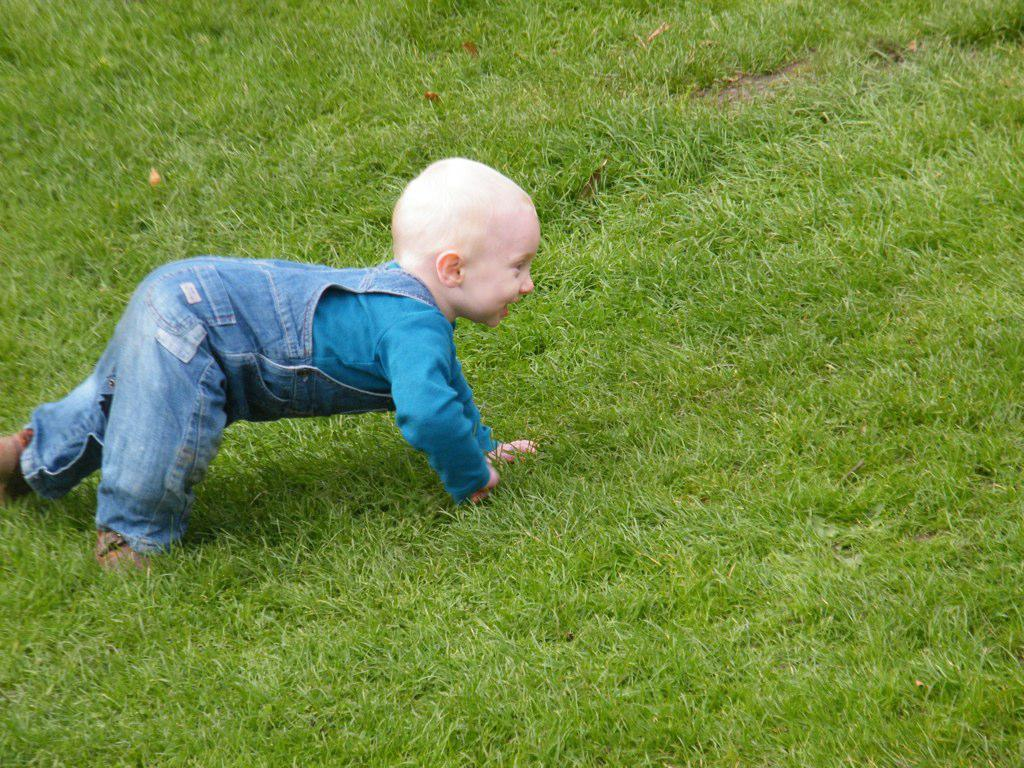Who is the main subject in the image? There is a child in the image. Where is the child located? The child is on a grass field. What type of knot is the child tying in the image? There is no knot present in the image; the child is simply on a grass field. 